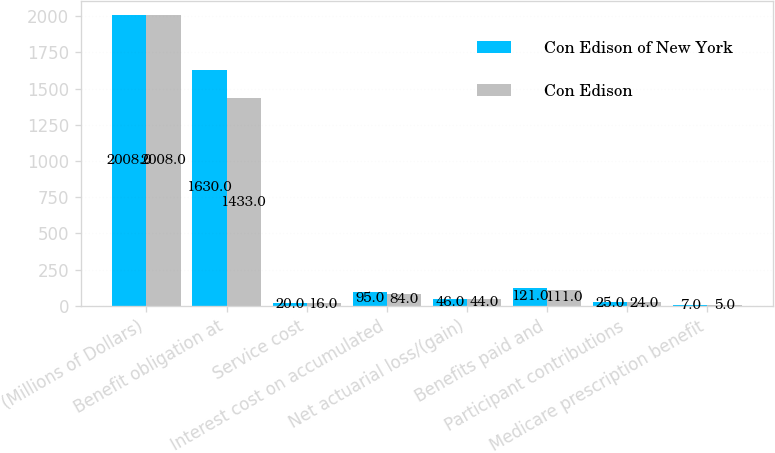Convert chart. <chart><loc_0><loc_0><loc_500><loc_500><stacked_bar_chart><ecel><fcel>(Millions of Dollars)<fcel>Benefit obligation at<fcel>Service cost<fcel>Interest cost on accumulated<fcel>Net actuarial loss/(gain)<fcel>Benefits paid and<fcel>Participant contributions<fcel>Medicare prescription benefit<nl><fcel>Con Edison of New York<fcel>2008<fcel>1630<fcel>20<fcel>95<fcel>46<fcel>121<fcel>25<fcel>7<nl><fcel>Con Edison<fcel>2008<fcel>1433<fcel>16<fcel>84<fcel>44<fcel>111<fcel>24<fcel>5<nl></chart> 